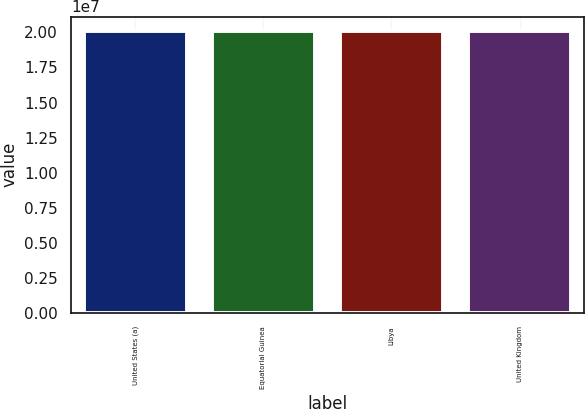Convert chart to OTSL. <chart><loc_0><loc_0><loc_500><loc_500><bar_chart><fcel>United States (a)<fcel>Equatorial Guinea<fcel>Libya<fcel>United Kingdom<nl><fcel>2.0082e+07<fcel>2.0072e+07<fcel>2.0122e+07<fcel>2.0087e+07<nl></chart> 